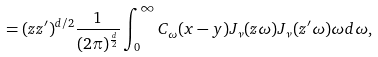<formula> <loc_0><loc_0><loc_500><loc_500>= ( z z ^ { \prime } ) ^ { d / 2 } \frac { 1 } { ( 2 \pi ) ^ { \frac { d } { 2 } } } \int _ { 0 } ^ { \infty } C _ { \omega } ( x - y ) J _ { \nu } ( z \omega ) J _ { \nu } ( z ^ { \prime } \omega ) \omega d \omega ,</formula> 